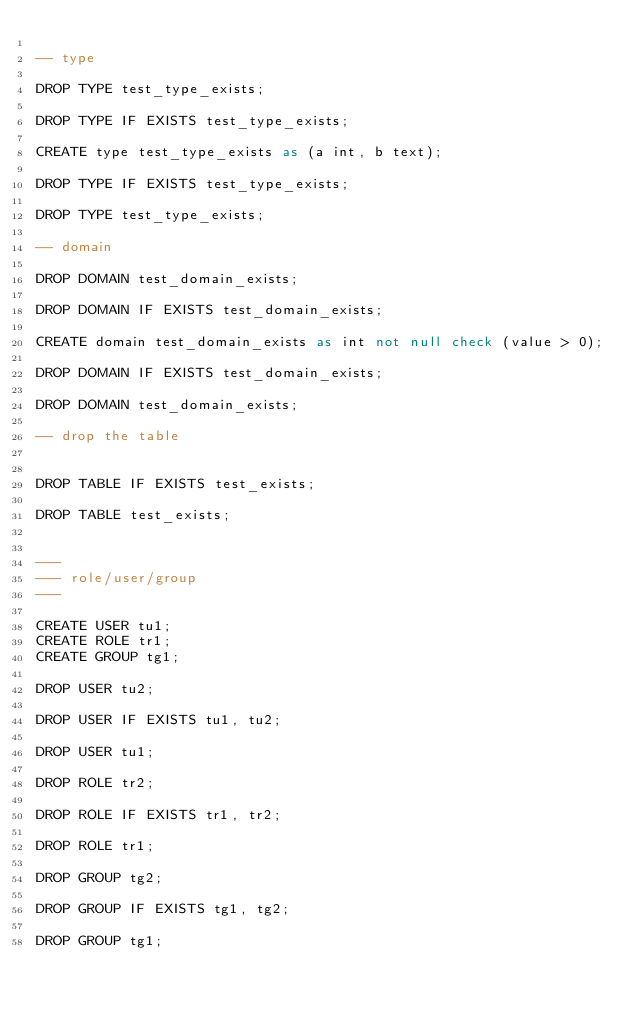Convert code to text. <code><loc_0><loc_0><loc_500><loc_500><_SQL_>
-- type

DROP TYPE test_type_exists;

DROP TYPE IF EXISTS test_type_exists;

CREATE type test_type_exists as (a int, b text);

DROP TYPE IF EXISTS test_type_exists;

DROP TYPE test_type_exists;

-- domain

DROP DOMAIN test_domain_exists;

DROP DOMAIN IF EXISTS test_domain_exists;

CREATE domain test_domain_exists as int not null check (value > 0);

DROP DOMAIN IF EXISTS test_domain_exists;

DROP DOMAIN test_domain_exists;

-- drop the table


DROP TABLE IF EXISTS test_exists;

DROP TABLE test_exists;


---
--- role/user/group
---

CREATE USER tu1;
CREATE ROLE tr1;
CREATE GROUP tg1;

DROP USER tu2;

DROP USER IF EXISTS tu1, tu2;

DROP USER tu1;

DROP ROLE tr2;

DROP ROLE IF EXISTS tr1, tr2;

DROP ROLE tr1;

DROP GROUP tg2;

DROP GROUP IF EXISTS tg1, tg2;

DROP GROUP tg1;
</code> 